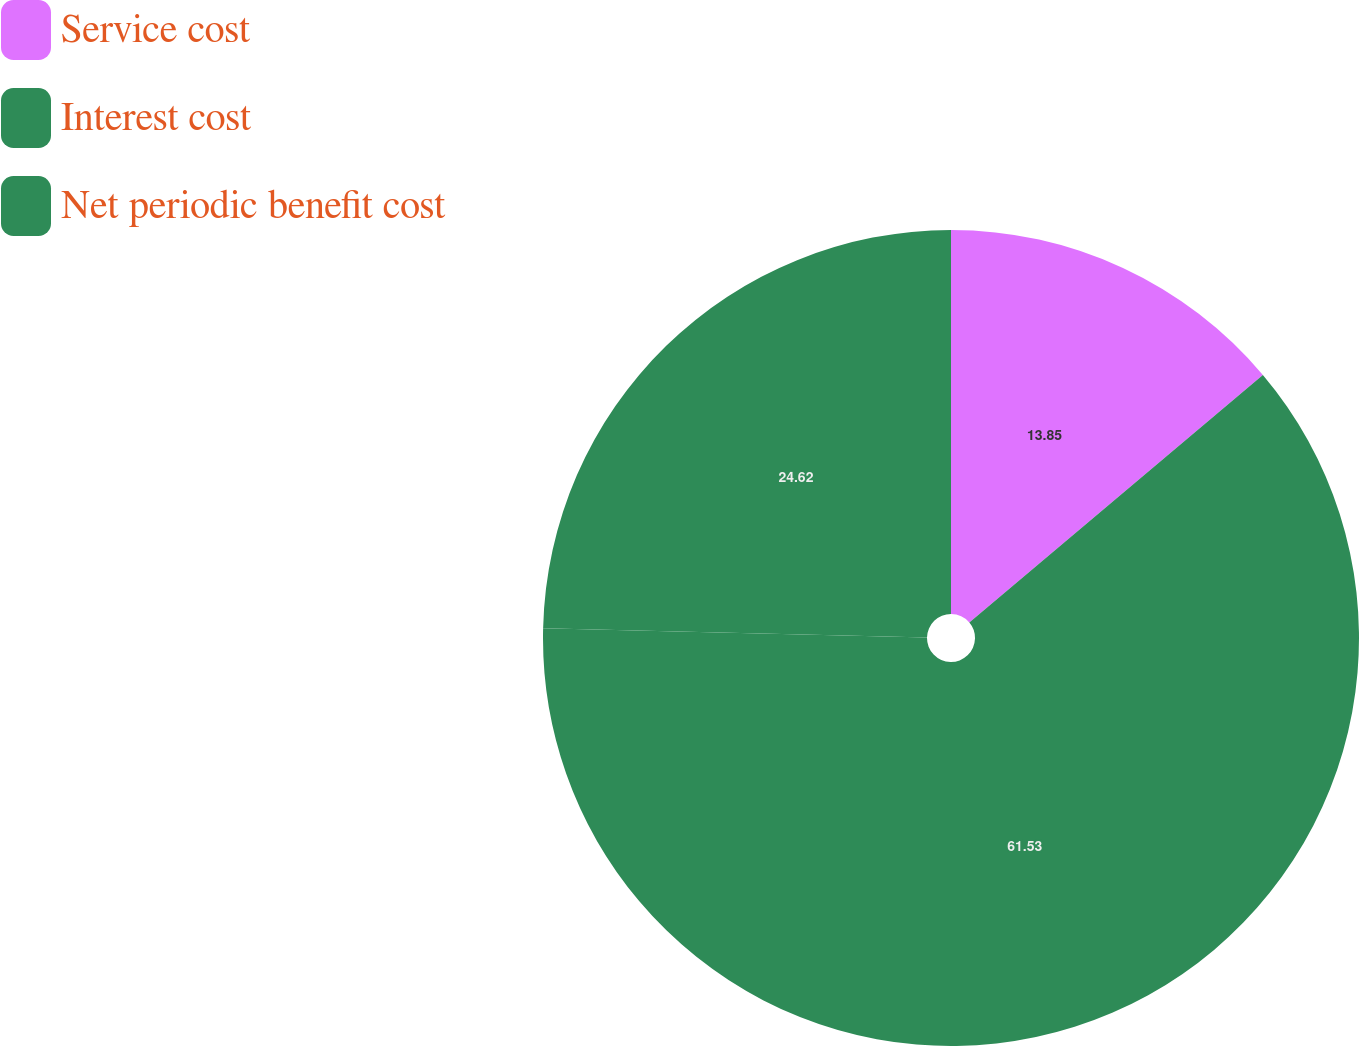Convert chart. <chart><loc_0><loc_0><loc_500><loc_500><pie_chart><fcel>Service cost<fcel>Interest cost<fcel>Net periodic benefit cost<nl><fcel>13.85%<fcel>61.54%<fcel>24.62%<nl></chart> 